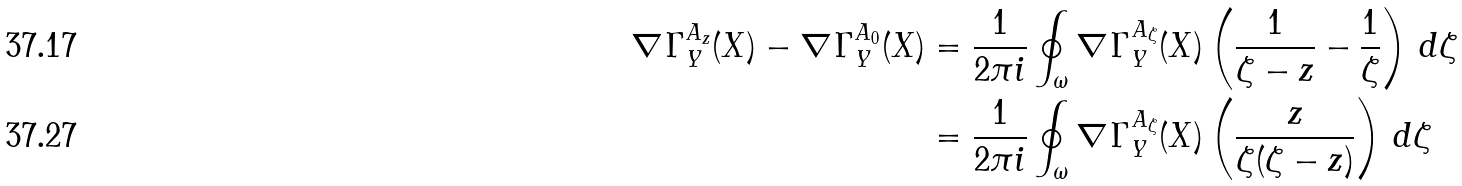Convert formula to latex. <formula><loc_0><loc_0><loc_500><loc_500>\nabla \Gamma ^ { A _ { z } } _ { Y } ( X ) - \nabla \Gamma ^ { A _ { 0 } } _ { Y } ( X ) & = \frac { 1 } { 2 \pi i } \oint _ { \omega } \nabla \Gamma ^ { A _ { \zeta } } _ { Y } ( X ) \left ( \frac { 1 } { \zeta - z } - \frac { 1 } { \zeta } \right ) \, d \zeta \\ & = \frac { 1 } { 2 \pi i } \oint _ { \omega } \nabla \Gamma ^ { A _ { \zeta } } _ { Y } ( X ) \left ( \frac { z } { \zeta ( \zeta - z ) } \right ) \, d \zeta</formula> 